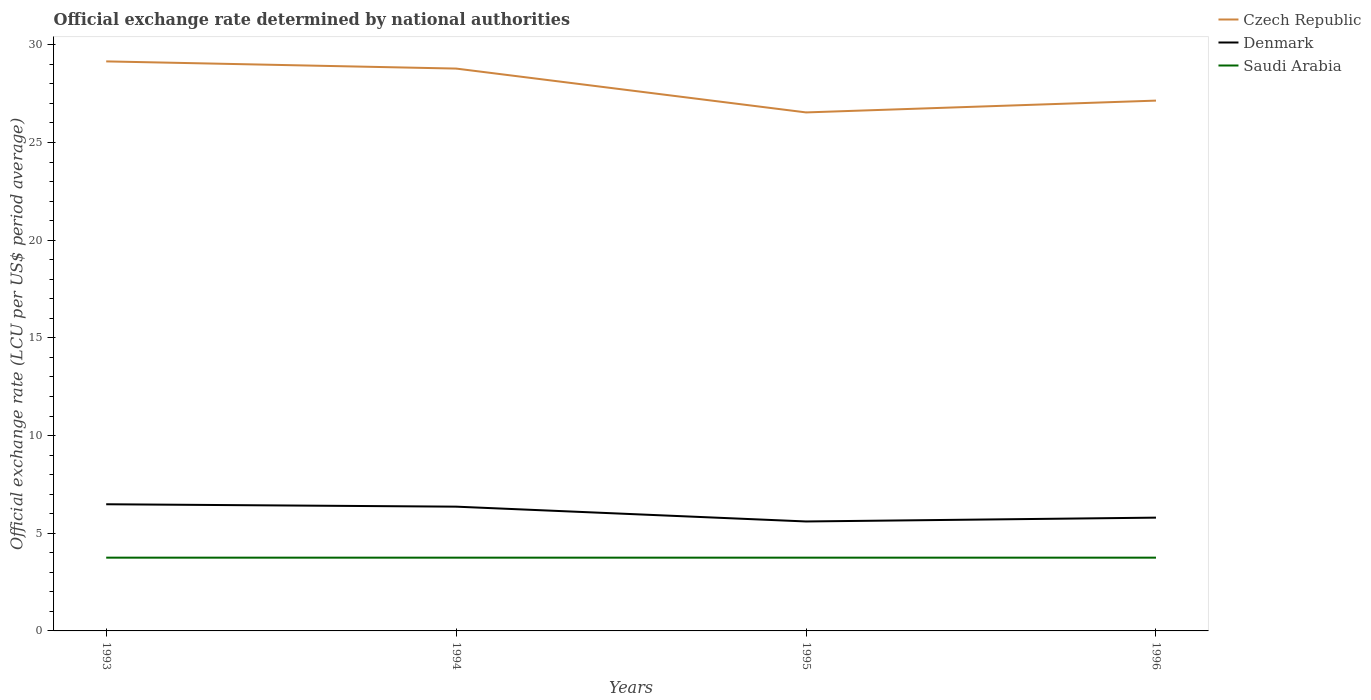Across all years, what is the maximum official exchange rate in Saudi Arabia?
Provide a succinct answer. 3.75. What is the total official exchange rate in Denmark in the graph?
Keep it short and to the point. 0.56. What is the difference between the highest and the second highest official exchange rate in Denmark?
Give a very brief answer. 0.88. What is the difference between the highest and the lowest official exchange rate in Denmark?
Offer a very short reply. 2. How many years are there in the graph?
Make the answer very short. 4. Does the graph contain grids?
Make the answer very short. No. What is the title of the graph?
Your answer should be compact. Official exchange rate determined by national authorities. Does "Angola" appear as one of the legend labels in the graph?
Ensure brevity in your answer.  No. What is the label or title of the X-axis?
Provide a succinct answer. Years. What is the label or title of the Y-axis?
Give a very brief answer. Official exchange rate (LCU per US$ period average). What is the Official exchange rate (LCU per US$ period average) of Czech Republic in 1993?
Offer a very short reply. 29.15. What is the Official exchange rate (LCU per US$ period average) of Denmark in 1993?
Provide a succinct answer. 6.48. What is the Official exchange rate (LCU per US$ period average) of Saudi Arabia in 1993?
Give a very brief answer. 3.75. What is the Official exchange rate (LCU per US$ period average) of Czech Republic in 1994?
Offer a very short reply. 28.79. What is the Official exchange rate (LCU per US$ period average) in Denmark in 1994?
Offer a very short reply. 6.36. What is the Official exchange rate (LCU per US$ period average) of Saudi Arabia in 1994?
Make the answer very short. 3.75. What is the Official exchange rate (LCU per US$ period average) in Czech Republic in 1995?
Ensure brevity in your answer.  26.54. What is the Official exchange rate (LCU per US$ period average) of Denmark in 1995?
Offer a terse response. 5.6. What is the Official exchange rate (LCU per US$ period average) in Saudi Arabia in 1995?
Make the answer very short. 3.75. What is the Official exchange rate (LCU per US$ period average) of Czech Republic in 1996?
Your answer should be very brief. 27.14. What is the Official exchange rate (LCU per US$ period average) in Denmark in 1996?
Your answer should be very brief. 5.8. What is the Official exchange rate (LCU per US$ period average) in Saudi Arabia in 1996?
Make the answer very short. 3.75. Across all years, what is the maximum Official exchange rate (LCU per US$ period average) of Czech Republic?
Provide a succinct answer. 29.15. Across all years, what is the maximum Official exchange rate (LCU per US$ period average) in Denmark?
Offer a very short reply. 6.48. Across all years, what is the maximum Official exchange rate (LCU per US$ period average) of Saudi Arabia?
Make the answer very short. 3.75. Across all years, what is the minimum Official exchange rate (LCU per US$ period average) in Czech Republic?
Provide a succinct answer. 26.54. Across all years, what is the minimum Official exchange rate (LCU per US$ period average) of Denmark?
Your answer should be very brief. 5.6. Across all years, what is the minimum Official exchange rate (LCU per US$ period average) in Saudi Arabia?
Your answer should be compact. 3.75. What is the total Official exchange rate (LCU per US$ period average) of Czech Republic in the graph?
Ensure brevity in your answer.  111.62. What is the total Official exchange rate (LCU per US$ period average) of Denmark in the graph?
Make the answer very short. 24.25. What is the difference between the Official exchange rate (LCU per US$ period average) in Czech Republic in 1993 and that in 1994?
Give a very brief answer. 0.37. What is the difference between the Official exchange rate (LCU per US$ period average) in Denmark in 1993 and that in 1994?
Your answer should be compact. 0.12. What is the difference between the Official exchange rate (LCU per US$ period average) in Czech Republic in 1993 and that in 1995?
Provide a short and direct response. 2.61. What is the difference between the Official exchange rate (LCU per US$ period average) in Denmark in 1993 and that in 1995?
Your answer should be compact. 0.88. What is the difference between the Official exchange rate (LCU per US$ period average) in Czech Republic in 1993 and that in 1996?
Your response must be concise. 2.01. What is the difference between the Official exchange rate (LCU per US$ period average) of Denmark in 1993 and that in 1996?
Offer a terse response. 0.69. What is the difference between the Official exchange rate (LCU per US$ period average) in Czech Republic in 1994 and that in 1995?
Your answer should be very brief. 2.24. What is the difference between the Official exchange rate (LCU per US$ period average) of Denmark in 1994 and that in 1995?
Make the answer very short. 0.76. What is the difference between the Official exchange rate (LCU per US$ period average) in Saudi Arabia in 1994 and that in 1995?
Your answer should be compact. 0. What is the difference between the Official exchange rate (LCU per US$ period average) in Czech Republic in 1994 and that in 1996?
Give a very brief answer. 1.64. What is the difference between the Official exchange rate (LCU per US$ period average) of Denmark in 1994 and that in 1996?
Provide a succinct answer. 0.56. What is the difference between the Official exchange rate (LCU per US$ period average) of Saudi Arabia in 1994 and that in 1996?
Your answer should be very brief. 0. What is the difference between the Official exchange rate (LCU per US$ period average) in Czech Republic in 1995 and that in 1996?
Your answer should be compact. -0.6. What is the difference between the Official exchange rate (LCU per US$ period average) in Denmark in 1995 and that in 1996?
Your answer should be compact. -0.2. What is the difference between the Official exchange rate (LCU per US$ period average) in Czech Republic in 1993 and the Official exchange rate (LCU per US$ period average) in Denmark in 1994?
Give a very brief answer. 22.79. What is the difference between the Official exchange rate (LCU per US$ period average) of Czech Republic in 1993 and the Official exchange rate (LCU per US$ period average) of Saudi Arabia in 1994?
Offer a very short reply. 25.4. What is the difference between the Official exchange rate (LCU per US$ period average) of Denmark in 1993 and the Official exchange rate (LCU per US$ period average) of Saudi Arabia in 1994?
Your answer should be compact. 2.73. What is the difference between the Official exchange rate (LCU per US$ period average) in Czech Republic in 1993 and the Official exchange rate (LCU per US$ period average) in Denmark in 1995?
Ensure brevity in your answer.  23.55. What is the difference between the Official exchange rate (LCU per US$ period average) of Czech Republic in 1993 and the Official exchange rate (LCU per US$ period average) of Saudi Arabia in 1995?
Offer a terse response. 25.4. What is the difference between the Official exchange rate (LCU per US$ period average) of Denmark in 1993 and the Official exchange rate (LCU per US$ period average) of Saudi Arabia in 1995?
Ensure brevity in your answer.  2.73. What is the difference between the Official exchange rate (LCU per US$ period average) in Czech Republic in 1993 and the Official exchange rate (LCU per US$ period average) in Denmark in 1996?
Offer a terse response. 23.35. What is the difference between the Official exchange rate (LCU per US$ period average) in Czech Republic in 1993 and the Official exchange rate (LCU per US$ period average) in Saudi Arabia in 1996?
Your response must be concise. 25.4. What is the difference between the Official exchange rate (LCU per US$ period average) of Denmark in 1993 and the Official exchange rate (LCU per US$ period average) of Saudi Arabia in 1996?
Provide a short and direct response. 2.73. What is the difference between the Official exchange rate (LCU per US$ period average) of Czech Republic in 1994 and the Official exchange rate (LCU per US$ period average) of Denmark in 1995?
Offer a very short reply. 23.18. What is the difference between the Official exchange rate (LCU per US$ period average) of Czech Republic in 1994 and the Official exchange rate (LCU per US$ period average) of Saudi Arabia in 1995?
Provide a succinct answer. 25.04. What is the difference between the Official exchange rate (LCU per US$ period average) in Denmark in 1994 and the Official exchange rate (LCU per US$ period average) in Saudi Arabia in 1995?
Offer a very short reply. 2.61. What is the difference between the Official exchange rate (LCU per US$ period average) of Czech Republic in 1994 and the Official exchange rate (LCU per US$ period average) of Denmark in 1996?
Keep it short and to the point. 22.99. What is the difference between the Official exchange rate (LCU per US$ period average) in Czech Republic in 1994 and the Official exchange rate (LCU per US$ period average) in Saudi Arabia in 1996?
Your answer should be very brief. 25.04. What is the difference between the Official exchange rate (LCU per US$ period average) of Denmark in 1994 and the Official exchange rate (LCU per US$ period average) of Saudi Arabia in 1996?
Offer a terse response. 2.61. What is the difference between the Official exchange rate (LCU per US$ period average) in Czech Republic in 1995 and the Official exchange rate (LCU per US$ period average) in Denmark in 1996?
Your response must be concise. 20.74. What is the difference between the Official exchange rate (LCU per US$ period average) in Czech Republic in 1995 and the Official exchange rate (LCU per US$ period average) in Saudi Arabia in 1996?
Ensure brevity in your answer.  22.79. What is the difference between the Official exchange rate (LCU per US$ period average) in Denmark in 1995 and the Official exchange rate (LCU per US$ period average) in Saudi Arabia in 1996?
Your answer should be compact. 1.85. What is the average Official exchange rate (LCU per US$ period average) of Czech Republic per year?
Your answer should be very brief. 27.91. What is the average Official exchange rate (LCU per US$ period average) of Denmark per year?
Provide a short and direct response. 6.06. What is the average Official exchange rate (LCU per US$ period average) in Saudi Arabia per year?
Make the answer very short. 3.75. In the year 1993, what is the difference between the Official exchange rate (LCU per US$ period average) of Czech Republic and Official exchange rate (LCU per US$ period average) of Denmark?
Offer a terse response. 22.67. In the year 1993, what is the difference between the Official exchange rate (LCU per US$ period average) in Czech Republic and Official exchange rate (LCU per US$ period average) in Saudi Arabia?
Offer a very short reply. 25.4. In the year 1993, what is the difference between the Official exchange rate (LCU per US$ period average) in Denmark and Official exchange rate (LCU per US$ period average) in Saudi Arabia?
Provide a short and direct response. 2.73. In the year 1994, what is the difference between the Official exchange rate (LCU per US$ period average) of Czech Republic and Official exchange rate (LCU per US$ period average) of Denmark?
Give a very brief answer. 22.42. In the year 1994, what is the difference between the Official exchange rate (LCU per US$ period average) in Czech Republic and Official exchange rate (LCU per US$ period average) in Saudi Arabia?
Your response must be concise. 25.04. In the year 1994, what is the difference between the Official exchange rate (LCU per US$ period average) in Denmark and Official exchange rate (LCU per US$ period average) in Saudi Arabia?
Make the answer very short. 2.61. In the year 1995, what is the difference between the Official exchange rate (LCU per US$ period average) of Czech Republic and Official exchange rate (LCU per US$ period average) of Denmark?
Ensure brevity in your answer.  20.94. In the year 1995, what is the difference between the Official exchange rate (LCU per US$ period average) of Czech Republic and Official exchange rate (LCU per US$ period average) of Saudi Arabia?
Your answer should be very brief. 22.79. In the year 1995, what is the difference between the Official exchange rate (LCU per US$ period average) of Denmark and Official exchange rate (LCU per US$ period average) of Saudi Arabia?
Keep it short and to the point. 1.85. In the year 1996, what is the difference between the Official exchange rate (LCU per US$ period average) in Czech Republic and Official exchange rate (LCU per US$ period average) in Denmark?
Keep it short and to the point. 21.35. In the year 1996, what is the difference between the Official exchange rate (LCU per US$ period average) in Czech Republic and Official exchange rate (LCU per US$ period average) in Saudi Arabia?
Offer a very short reply. 23.39. In the year 1996, what is the difference between the Official exchange rate (LCU per US$ period average) of Denmark and Official exchange rate (LCU per US$ period average) of Saudi Arabia?
Make the answer very short. 2.05. What is the ratio of the Official exchange rate (LCU per US$ period average) in Czech Republic in 1993 to that in 1994?
Provide a short and direct response. 1.01. What is the ratio of the Official exchange rate (LCU per US$ period average) of Denmark in 1993 to that in 1994?
Give a very brief answer. 1.02. What is the ratio of the Official exchange rate (LCU per US$ period average) of Czech Republic in 1993 to that in 1995?
Your response must be concise. 1.1. What is the ratio of the Official exchange rate (LCU per US$ period average) of Denmark in 1993 to that in 1995?
Keep it short and to the point. 1.16. What is the ratio of the Official exchange rate (LCU per US$ period average) of Saudi Arabia in 1993 to that in 1995?
Provide a succinct answer. 1. What is the ratio of the Official exchange rate (LCU per US$ period average) of Czech Republic in 1993 to that in 1996?
Ensure brevity in your answer.  1.07. What is the ratio of the Official exchange rate (LCU per US$ period average) in Denmark in 1993 to that in 1996?
Your answer should be compact. 1.12. What is the ratio of the Official exchange rate (LCU per US$ period average) of Czech Republic in 1994 to that in 1995?
Give a very brief answer. 1.08. What is the ratio of the Official exchange rate (LCU per US$ period average) of Denmark in 1994 to that in 1995?
Keep it short and to the point. 1.14. What is the ratio of the Official exchange rate (LCU per US$ period average) in Saudi Arabia in 1994 to that in 1995?
Provide a short and direct response. 1. What is the ratio of the Official exchange rate (LCU per US$ period average) of Czech Republic in 1994 to that in 1996?
Your response must be concise. 1.06. What is the ratio of the Official exchange rate (LCU per US$ period average) in Denmark in 1994 to that in 1996?
Make the answer very short. 1.1. What is the ratio of the Official exchange rate (LCU per US$ period average) in Saudi Arabia in 1994 to that in 1996?
Offer a very short reply. 1. What is the ratio of the Official exchange rate (LCU per US$ period average) in Czech Republic in 1995 to that in 1996?
Offer a very short reply. 0.98. What is the ratio of the Official exchange rate (LCU per US$ period average) of Denmark in 1995 to that in 1996?
Offer a terse response. 0.97. What is the ratio of the Official exchange rate (LCU per US$ period average) in Saudi Arabia in 1995 to that in 1996?
Make the answer very short. 1. What is the difference between the highest and the second highest Official exchange rate (LCU per US$ period average) of Czech Republic?
Keep it short and to the point. 0.37. What is the difference between the highest and the second highest Official exchange rate (LCU per US$ period average) of Denmark?
Your answer should be very brief. 0.12. What is the difference between the highest and the second highest Official exchange rate (LCU per US$ period average) of Saudi Arabia?
Give a very brief answer. 0. What is the difference between the highest and the lowest Official exchange rate (LCU per US$ period average) of Czech Republic?
Offer a terse response. 2.61. What is the difference between the highest and the lowest Official exchange rate (LCU per US$ period average) of Denmark?
Provide a short and direct response. 0.88. What is the difference between the highest and the lowest Official exchange rate (LCU per US$ period average) of Saudi Arabia?
Your answer should be very brief. 0. 